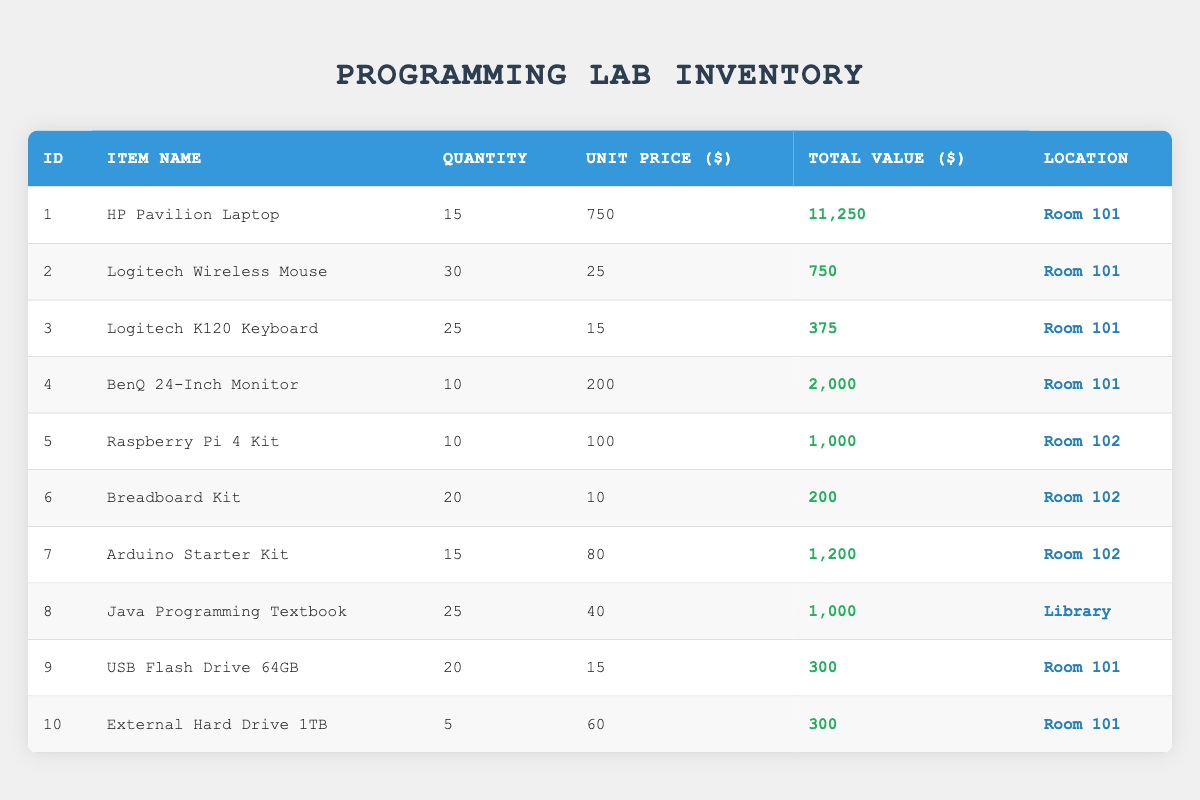What is the total quantity of HP Pavilion Laptops in the inventory? The table indicates the quantity of HP Pavilion Laptops is listed as 15 under the "Quantity" column corresponding to "HP Pavilion Laptop."
Answer: 15 What is the total value of all the supplies located in Room 101? To find this, we sum the total values of all items listed in Room 101: 11250 (Laptop) + 750 (Mouse) + 375 (Keyboard) + 2000 (Monitor) + 300 (Flash Drive) + 300 (External Hard Drive) = 16875.
Answer: 16875 Is there a Raspberry Pi 4 Kit available in the inventory? The table shows the item "Raspberry Pi 4 Kit," which indicates that it is present in the inventory.
Answer: Yes How many more Logitech Wireless Mice are there compared to External Hard Drives? The quantity for Logitech Wireless Mouse is 30, and for External Hard Drive, it is 5. The difference is 30 - 5 = 25.
Answer: 25 What is the average unit price of the items in Room 102? First, we identify the items in Room 102: Raspberry Pi Kit ($100), Breadboard Kit ($10), and Arduino Starter Kit ($80). The average unit price is calculated as (100 + 10 + 80) / 3 = 190 / 3 = 63.33.
Answer: 63.33 Which item has the highest total value in the inventory? By reviewing the "Total Value" column, we see that the HP Pavilion Laptop has the highest total value at 11250, compared to others.
Answer: HP Pavilion Laptop How many total items are located in Room 102? The items in Room 102 are Raspberry Pi 4 Kit (10), Breadboard Kit (20), and Arduino Starter Kit (15). Therefore, the total quantity is 10 + 20 + 15 = 45.
Answer: 45 Are there more USB Flash Drives than Arduino Starter Kits? The quantity of USB Flash Drives is 20, while the quantity of Arduino Starter Kits is 15. Since 20 is greater than 15, the statement is true.
Answer: Yes What is the total expenditure for all items if an External Hard Drive is removed from Room 101? First, we find the total value of items: 11250 + 750 + 375 + 2000 + 1000 + 200 + 1200 + 1000 + 300 from USB and 300 from External Hard Drive amounting to 18475. Removing the External Hard Drive, we subtract 300 resulting in 18175 as the new total.
Answer: 18175 